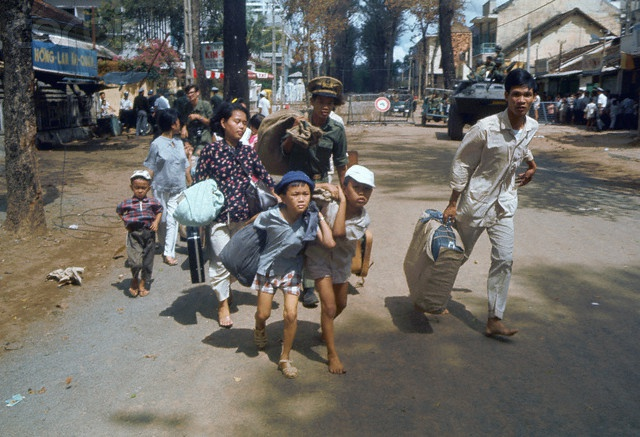Describe the objects in this image and their specific colors. I can see people in black, gray, darkgray, and lightgray tones, people in black, gray, darkgray, and maroon tones, people in black, gray, and darkgray tones, people in black, gray, and maroon tones, and suitcase in black, gray, and darkgray tones in this image. 